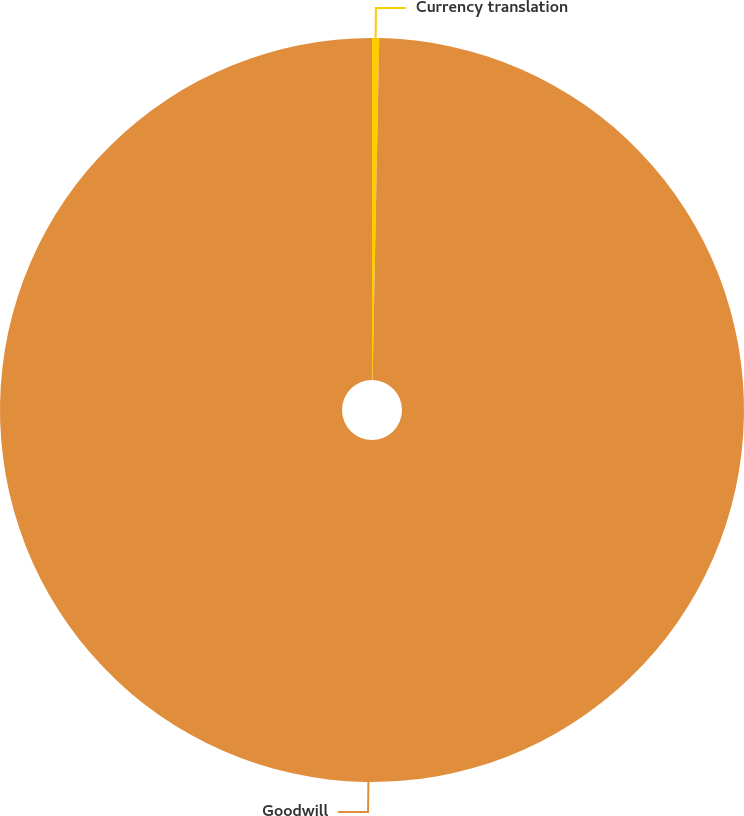Convert chart to OTSL. <chart><loc_0><loc_0><loc_500><loc_500><pie_chart><fcel>Currency translation<fcel>Goodwill<nl><fcel>0.31%<fcel>99.69%<nl></chart> 